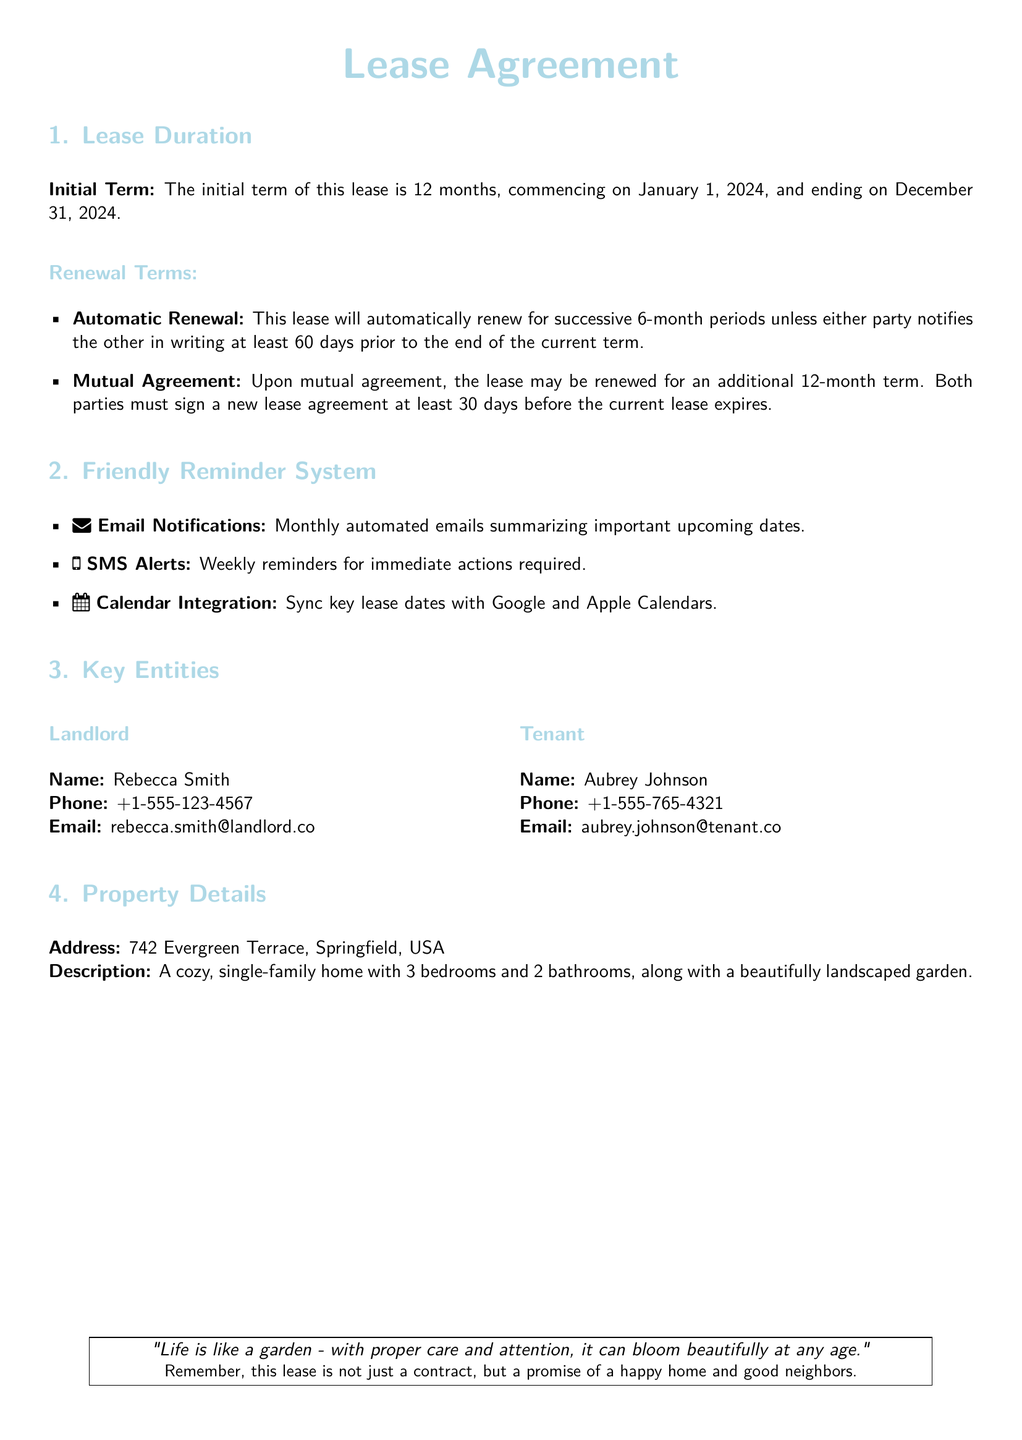What is the initial term of the lease? The initial term of the lease is stated as 12 months, commencing on January 1, 2024.
Answer: 12 months When does the lease start? The document specifies that the lease commences on January 1, 2024.
Answer: January 1, 2024 How long will the lease automatically renew for each period? The lease will automatically renew for successive 6-month periods unless notice is given.
Answer: 6 months What is the notice period required for lease termination? The lease requires notifying the other party at least 60 days prior to the end of the current term.
Answer: 60 days How many days before expiration must renewal be agreed upon mutually? The renewal must be agreed upon at least 30 days before the current lease expires.
Answer: 30 days What type of notification system is mentioned for reminders? The document mentions a friendly reminder system that includes email notifications, SMS alerts, and calendar integration.
Answer: Email notifications, SMS alerts, and calendar integration Who is the landlord's name? The landlord's name is provided in the document.
Answer: Rebecca Smith What is the property description? The document describes the property as a cozy, single-family home with specific features.
Answer: A cozy, single-family home with 3 bedrooms and 2 bathrooms Is the lease agreement a promise of a happy home? The document includes a quote about the nature of the lease agreement as a home promise.
Answer: Yes 